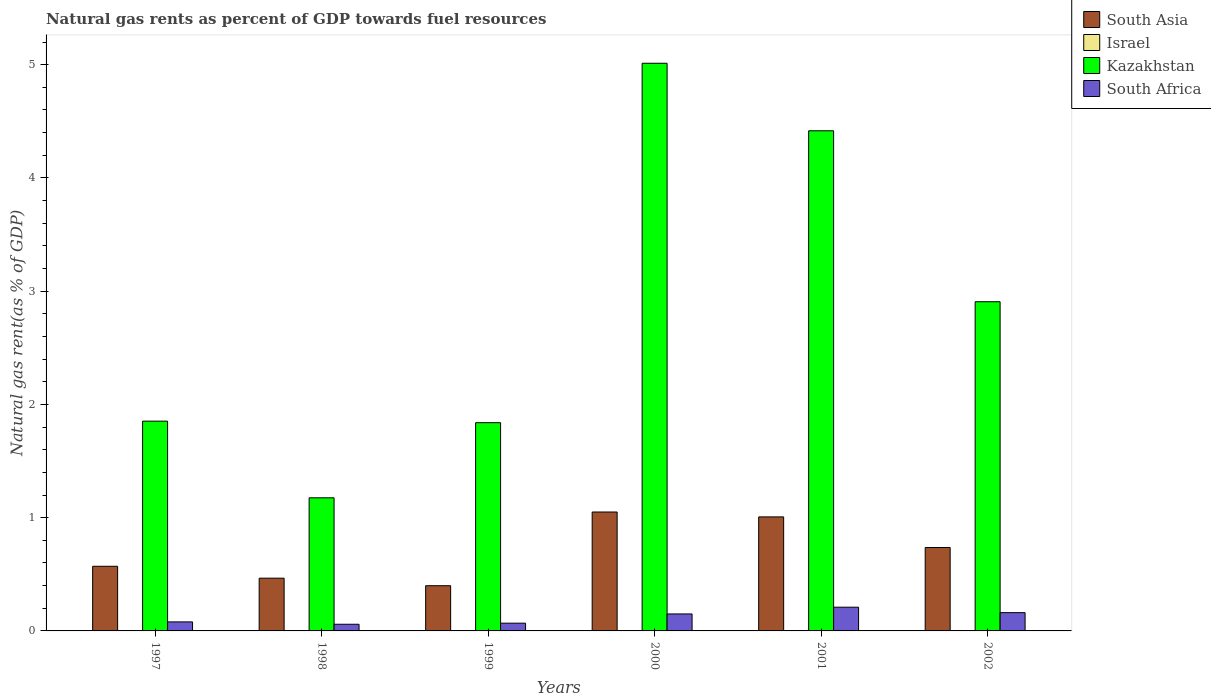How many groups of bars are there?
Your answer should be compact. 6. How many bars are there on the 4th tick from the left?
Provide a short and direct response. 4. How many bars are there on the 1st tick from the right?
Make the answer very short. 4. What is the natural gas rent in Kazakhstan in 2000?
Keep it short and to the point. 5.01. Across all years, what is the maximum natural gas rent in South Asia?
Make the answer very short. 1.05. Across all years, what is the minimum natural gas rent in Kazakhstan?
Your answer should be compact. 1.18. In which year was the natural gas rent in South Asia maximum?
Offer a terse response. 2000. In which year was the natural gas rent in South Africa minimum?
Your answer should be compact. 1998. What is the total natural gas rent in South Asia in the graph?
Offer a terse response. 4.23. What is the difference between the natural gas rent in Israel in 1997 and that in 2002?
Your answer should be compact. 0. What is the difference between the natural gas rent in South Africa in 1998 and the natural gas rent in South Asia in 2001?
Keep it short and to the point. -0.95. What is the average natural gas rent in South Africa per year?
Keep it short and to the point. 0.12. In the year 2000, what is the difference between the natural gas rent in Israel and natural gas rent in Kazakhstan?
Offer a very short reply. -5.01. What is the ratio of the natural gas rent in Kazakhstan in 1999 to that in 2001?
Offer a very short reply. 0.42. Is the natural gas rent in South Asia in 1999 less than that in 2000?
Your answer should be compact. Yes. Is the difference between the natural gas rent in Israel in 1997 and 1998 greater than the difference between the natural gas rent in Kazakhstan in 1997 and 1998?
Give a very brief answer. No. What is the difference between the highest and the second highest natural gas rent in Israel?
Give a very brief answer. 0. What is the difference between the highest and the lowest natural gas rent in South Asia?
Ensure brevity in your answer.  0.65. In how many years, is the natural gas rent in South Africa greater than the average natural gas rent in South Africa taken over all years?
Provide a short and direct response. 3. Is the sum of the natural gas rent in Kazakhstan in 1998 and 2000 greater than the maximum natural gas rent in South Asia across all years?
Give a very brief answer. Yes. How many bars are there?
Give a very brief answer. 24. Are all the bars in the graph horizontal?
Provide a short and direct response. No. How many years are there in the graph?
Your answer should be compact. 6. Are the values on the major ticks of Y-axis written in scientific E-notation?
Make the answer very short. No. Where does the legend appear in the graph?
Provide a succinct answer. Top right. How are the legend labels stacked?
Give a very brief answer. Vertical. What is the title of the graph?
Your answer should be very brief. Natural gas rents as percent of GDP towards fuel resources. Does "Italy" appear as one of the legend labels in the graph?
Offer a very short reply. No. What is the label or title of the Y-axis?
Provide a short and direct response. Natural gas rent(as % of GDP). What is the Natural gas rent(as % of GDP) of South Asia in 1997?
Your answer should be compact. 0.57. What is the Natural gas rent(as % of GDP) of Israel in 1997?
Offer a terse response. 0. What is the Natural gas rent(as % of GDP) of Kazakhstan in 1997?
Give a very brief answer. 1.85. What is the Natural gas rent(as % of GDP) in South Africa in 1997?
Provide a succinct answer. 0.08. What is the Natural gas rent(as % of GDP) of South Asia in 1998?
Offer a very short reply. 0.47. What is the Natural gas rent(as % of GDP) of Israel in 1998?
Offer a very short reply. 0. What is the Natural gas rent(as % of GDP) of Kazakhstan in 1998?
Offer a very short reply. 1.18. What is the Natural gas rent(as % of GDP) of South Africa in 1998?
Your response must be concise. 0.06. What is the Natural gas rent(as % of GDP) of South Asia in 1999?
Give a very brief answer. 0.4. What is the Natural gas rent(as % of GDP) in Israel in 1999?
Your response must be concise. 0. What is the Natural gas rent(as % of GDP) of Kazakhstan in 1999?
Your response must be concise. 1.84. What is the Natural gas rent(as % of GDP) in South Africa in 1999?
Keep it short and to the point. 0.07. What is the Natural gas rent(as % of GDP) of South Asia in 2000?
Keep it short and to the point. 1.05. What is the Natural gas rent(as % of GDP) in Israel in 2000?
Offer a terse response. 0. What is the Natural gas rent(as % of GDP) in Kazakhstan in 2000?
Keep it short and to the point. 5.01. What is the Natural gas rent(as % of GDP) in South Africa in 2000?
Make the answer very short. 0.15. What is the Natural gas rent(as % of GDP) in South Asia in 2001?
Ensure brevity in your answer.  1.01. What is the Natural gas rent(as % of GDP) of Israel in 2001?
Provide a succinct answer. 0. What is the Natural gas rent(as % of GDP) in Kazakhstan in 2001?
Provide a short and direct response. 4.42. What is the Natural gas rent(as % of GDP) of South Africa in 2001?
Your answer should be compact. 0.21. What is the Natural gas rent(as % of GDP) of South Asia in 2002?
Your response must be concise. 0.74. What is the Natural gas rent(as % of GDP) in Israel in 2002?
Make the answer very short. 0. What is the Natural gas rent(as % of GDP) in Kazakhstan in 2002?
Your answer should be very brief. 2.91. What is the Natural gas rent(as % of GDP) of South Africa in 2002?
Your answer should be very brief. 0.16. Across all years, what is the maximum Natural gas rent(as % of GDP) of South Asia?
Offer a terse response. 1.05. Across all years, what is the maximum Natural gas rent(as % of GDP) of Israel?
Ensure brevity in your answer.  0. Across all years, what is the maximum Natural gas rent(as % of GDP) of Kazakhstan?
Your response must be concise. 5.01. Across all years, what is the maximum Natural gas rent(as % of GDP) in South Africa?
Make the answer very short. 0.21. Across all years, what is the minimum Natural gas rent(as % of GDP) of South Asia?
Offer a very short reply. 0.4. Across all years, what is the minimum Natural gas rent(as % of GDP) in Israel?
Give a very brief answer. 0. Across all years, what is the minimum Natural gas rent(as % of GDP) of Kazakhstan?
Your answer should be very brief. 1.18. Across all years, what is the minimum Natural gas rent(as % of GDP) of South Africa?
Provide a short and direct response. 0.06. What is the total Natural gas rent(as % of GDP) in South Asia in the graph?
Your response must be concise. 4.23. What is the total Natural gas rent(as % of GDP) of Israel in the graph?
Give a very brief answer. 0. What is the total Natural gas rent(as % of GDP) in Kazakhstan in the graph?
Your response must be concise. 17.2. What is the total Natural gas rent(as % of GDP) of South Africa in the graph?
Provide a succinct answer. 0.73. What is the difference between the Natural gas rent(as % of GDP) in South Asia in 1997 and that in 1998?
Your answer should be compact. 0.11. What is the difference between the Natural gas rent(as % of GDP) in Kazakhstan in 1997 and that in 1998?
Provide a succinct answer. 0.68. What is the difference between the Natural gas rent(as % of GDP) of South Africa in 1997 and that in 1998?
Give a very brief answer. 0.02. What is the difference between the Natural gas rent(as % of GDP) in South Asia in 1997 and that in 1999?
Offer a terse response. 0.17. What is the difference between the Natural gas rent(as % of GDP) in Israel in 1997 and that in 1999?
Ensure brevity in your answer.  0. What is the difference between the Natural gas rent(as % of GDP) in Kazakhstan in 1997 and that in 1999?
Give a very brief answer. 0.01. What is the difference between the Natural gas rent(as % of GDP) of South Africa in 1997 and that in 1999?
Provide a short and direct response. 0.01. What is the difference between the Natural gas rent(as % of GDP) in South Asia in 1997 and that in 2000?
Provide a short and direct response. -0.48. What is the difference between the Natural gas rent(as % of GDP) of Kazakhstan in 1997 and that in 2000?
Offer a terse response. -3.16. What is the difference between the Natural gas rent(as % of GDP) in South Africa in 1997 and that in 2000?
Offer a terse response. -0.07. What is the difference between the Natural gas rent(as % of GDP) of South Asia in 1997 and that in 2001?
Offer a terse response. -0.44. What is the difference between the Natural gas rent(as % of GDP) of Kazakhstan in 1997 and that in 2001?
Your answer should be very brief. -2.56. What is the difference between the Natural gas rent(as % of GDP) of South Africa in 1997 and that in 2001?
Offer a terse response. -0.13. What is the difference between the Natural gas rent(as % of GDP) of South Asia in 1997 and that in 2002?
Offer a terse response. -0.17. What is the difference between the Natural gas rent(as % of GDP) of Israel in 1997 and that in 2002?
Your answer should be very brief. 0. What is the difference between the Natural gas rent(as % of GDP) of Kazakhstan in 1997 and that in 2002?
Provide a short and direct response. -1.05. What is the difference between the Natural gas rent(as % of GDP) in South Africa in 1997 and that in 2002?
Provide a succinct answer. -0.08. What is the difference between the Natural gas rent(as % of GDP) of South Asia in 1998 and that in 1999?
Your answer should be compact. 0.07. What is the difference between the Natural gas rent(as % of GDP) of Kazakhstan in 1998 and that in 1999?
Ensure brevity in your answer.  -0.66. What is the difference between the Natural gas rent(as % of GDP) in South Africa in 1998 and that in 1999?
Keep it short and to the point. -0.01. What is the difference between the Natural gas rent(as % of GDP) of South Asia in 1998 and that in 2000?
Your response must be concise. -0.58. What is the difference between the Natural gas rent(as % of GDP) in Israel in 1998 and that in 2000?
Your response must be concise. -0. What is the difference between the Natural gas rent(as % of GDP) in Kazakhstan in 1998 and that in 2000?
Make the answer very short. -3.84. What is the difference between the Natural gas rent(as % of GDP) of South Africa in 1998 and that in 2000?
Ensure brevity in your answer.  -0.09. What is the difference between the Natural gas rent(as % of GDP) in South Asia in 1998 and that in 2001?
Provide a succinct answer. -0.54. What is the difference between the Natural gas rent(as % of GDP) of Israel in 1998 and that in 2001?
Your answer should be very brief. -0. What is the difference between the Natural gas rent(as % of GDP) of Kazakhstan in 1998 and that in 2001?
Keep it short and to the point. -3.24. What is the difference between the Natural gas rent(as % of GDP) in South Africa in 1998 and that in 2001?
Ensure brevity in your answer.  -0.15. What is the difference between the Natural gas rent(as % of GDP) of South Asia in 1998 and that in 2002?
Provide a succinct answer. -0.27. What is the difference between the Natural gas rent(as % of GDP) in Israel in 1998 and that in 2002?
Ensure brevity in your answer.  -0. What is the difference between the Natural gas rent(as % of GDP) in Kazakhstan in 1998 and that in 2002?
Your response must be concise. -1.73. What is the difference between the Natural gas rent(as % of GDP) in South Africa in 1998 and that in 2002?
Give a very brief answer. -0.1. What is the difference between the Natural gas rent(as % of GDP) of South Asia in 1999 and that in 2000?
Provide a short and direct response. -0.65. What is the difference between the Natural gas rent(as % of GDP) in Israel in 1999 and that in 2000?
Your answer should be compact. -0. What is the difference between the Natural gas rent(as % of GDP) in Kazakhstan in 1999 and that in 2000?
Provide a succinct answer. -3.17. What is the difference between the Natural gas rent(as % of GDP) in South Africa in 1999 and that in 2000?
Keep it short and to the point. -0.08. What is the difference between the Natural gas rent(as % of GDP) of South Asia in 1999 and that in 2001?
Your answer should be very brief. -0.61. What is the difference between the Natural gas rent(as % of GDP) in Israel in 1999 and that in 2001?
Your answer should be compact. -0. What is the difference between the Natural gas rent(as % of GDP) of Kazakhstan in 1999 and that in 2001?
Provide a succinct answer. -2.58. What is the difference between the Natural gas rent(as % of GDP) in South Africa in 1999 and that in 2001?
Your response must be concise. -0.14. What is the difference between the Natural gas rent(as % of GDP) in South Asia in 1999 and that in 2002?
Make the answer very short. -0.34. What is the difference between the Natural gas rent(as % of GDP) of Israel in 1999 and that in 2002?
Provide a short and direct response. -0. What is the difference between the Natural gas rent(as % of GDP) in Kazakhstan in 1999 and that in 2002?
Give a very brief answer. -1.07. What is the difference between the Natural gas rent(as % of GDP) of South Africa in 1999 and that in 2002?
Your response must be concise. -0.09. What is the difference between the Natural gas rent(as % of GDP) in South Asia in 2000 and that in 2001?
Ensure brevity in your answer.  0.04. What is the difference between the Natural gas rent(as % of GDP) in Kazakhstan in 2000 and that in 2001?
Make the answer very short. 0.6. What is the difference between the Natural gas rent(as % of GDP) of South Africa in 2000 and that in 2001?
Offer a terse response. -0.06. What is the difference between the Natural gas rent(as % of GDP) in South Asia in 2000 and that in 2002?
Make the answer very short. 0.31. What is the difference between the Natural gas rent(as % of GDP) of Kazakhstan in 2000 and that in 2002?
Give a very brief answer. 2.11. What is the difference between the Natural gas rent(as % of GDP) of South Africa in 2000 and that in 2002?
Make the answer very short. -0.01. What is the difference between the Natural gas rent(as % of GDP) of South Asia in 2001 and that in 2002?
Offer a very short reply. 0.27. What is the difference between the Natural gas rent(as % of GDP) in Israel in 2001 and that in 2002?
Ensure brevity in your answer.  0. What is the difference between the Natural gas rent(as % of GDP) of Kazakhstan in 2001 and that in 2002?
Provide a short and direct response. 1.51. What is the difference between the Natural gas rent(as % of GDP) in South Africa in 2001 and that in 2002?
Provide a succinct answer. 0.05. What is the difference between the Natural gas rent(as % of GDP) in South Asia in 1997 and the Natural gas rent(as % of GDP) in Israel in 1998?
Offer a terse response. 0.57. What is the difference between the Natural gas rent(as % of GDP) of South Asia in 1997 and the Natural gas rent(as % of GDP) of Kazakhstan in 1998?
Provide a short and direct response. -0.6. What is the difference between the Natural gas rent(as % of GDP) in South Asia in 1997 and the Natural gas rent(as % of GDP) in South Africa in 1998?
Provide a succinct answer. 0.51. What is the difference between the Natural gas rent(as % of GDP) of Israel in 1997 and the Natural gas rent(as % of GDP) of Kazakhstan in 1998?
Provide a succinct answer. -1.17. What is the difference between the Natural gas rent(as % of GDP) of Israel in 1997 and the Natural gas rent(as % of GDP) of South Africa in 1998?
Offer a terse response. -0.06. What is the difference between the Natural gas rent(as % of GDP) in Kazakhstan in 1997 and the Natural gas rent(as % of GDP) in South Africa in 1998?
Provide a short and direct response. 1.79. What is the difference between the Natural gas rent(as % of GDP) of South Asia in 1997 and the Natural gas rent(as % of GDP) of Israel in 1999?
Your response must be concise. 0.57. What is the difference between the Natural gas rent(as % of GDP) in South Asia in 1997 and the Natural gas rent(as % of GDP) in Kazakhstan in 1999?
Provide a short and direct response. -1.27. What is the difference between the Natural gas rent(as % of GDP) of South Asia in 1997 and the Natural gas rent(as % of GDP) of South Africa in 1999?
Provide a succinct answer. 0.5. What is the difference between the Natural gas rent(as % of GDP) in Israel in 1997 and the Natural gas rent(as % of GDP) in Kazakhstan in 1999?
Offer a terse response. -1.84. What is the difference between the Natural gas rent(as % of GDP) in Israel in 1997 and the Natural gas rent(as % of GDP) in South Africa in 1999?
Make the answer very short. -0.07. What is the difference between the Natural gas rent(as % of GDP) in Kazakhstan in 1997 and the Natural gas rent(as % of GDP) in South Africa in 1999?
Your answer should be compact. 1.78. What is the difference between the Natural gas rent(as % of GDP) of South Asia in 1997 and the Natural gas rent(as % of GDP) of Israel in 2000?
Offer a very short reply. 0.57. What is the difference between the Natural gas rent(as % of GDP) of South Asia in 1997 and the Natural gas rent(as % of GDP) of Kazakhstan in 2000?
Ensure brevity in your answer.  -4.44. What is the difference between the Natural gas rent(as % of GDP) in South Asia in 1997 and the Natural gas rent(as % of GDP) in South Africa in 2000?
Provide a succinct answer. 0.42. What is the difference between the Natural gas rent(as % of GDP) of Israel in 1997 and the Natural gas rent(as % of GDP) of Kazakhstan in 2000?
Give a very brief answer. -5.01. What is the difference between the Natural gas rent(as % of GDP) of Israel in 1997 and the Natural gas rent(as % of GDP) of South Africa in 2000?
Provide a short and direct response. -0.15. What is the difference between the Natural gas rent(as % of GDP) in Kazakhstan in 1997 and the Natural gas rent(as % of GDP) in South Africa in 2000?
Give a very brief answer. 1.7. What is the difference between the Natural gas rent(as % of GDP) of South Asia in 1997 and the Natural gas rent(as % of GDP) of Israel in 2001?
Offer a very short reply. 0.57. What is the difference between the Natural gas rent(as % of GDP) in South Asia in 1997 and the Natural gas rent(as % of GDP) in Kazakhstan in 2001?
Ensure brevity in your answer.  -3.85. What is the difference between the Natural gas rent(as % of GDP) of South Asia in 1997 and the Natural gas rent(as % of GDP) of South Africa in 2001?
Make the answer very short. 0.36. What is the difference between the Natural gas rent(as % of GDP) in Israel in 1997 and the Natural gas rent(as % of GDP) in Kazakhstan in 2001?
Offer a terse response. -4.42. What is the difference between the Natural gas rent(as % of GDP) of Israel in 1997 and the Natural gas rent(as % of GDP) of South Africa in 2001?
Your answer should be very brief. -0.21. What is the difference between the Natural gas rent(as % of GDP) in Kazakhstan in 1997 and the Natural gas rent(as % of GDP) in South Africa in 2001?
Ensure brevity in your answer.  1.64. What is the difference between the Natural gas rent(as % of GDP) in South Asia in 1997 and the Natural gas rent(as % of GDP) in Israel in 2002?
Ensure brevity in your answer.  0.57. What is the difference between the Natural gas rent(as % of GDP) in South Asia in 1997 and the Natural gas rent(as % of GDP) in Kazakhstan in 2002?
Your answer should be compact. -2.34. What is the difference between the Natural gas rent(as % of GDP) of South Asia in 1997 and the Natural gas rent(as % of GDP) of South Africa in 2002?
Your response must be concise. 0.41. What is the difference between the Natural gas rent(as % of GDP) of Israel in 1997 and the Natural gas rent(as % of GDP) of Kazakhstan in 2002?
Ensure brevity in your answer.  -2.91. What is the difference between the Natural gas rent(as % of GDP) of Israel in 1997 and the Natural gas rent(as % of GDP) of South Africa in 2002?
Keep it short and to the point. -0.16. What is the difference between the Natural gas rent(as % of GDP) of Kazakhstan in 1997 and the Natural gas rent(as % of GDP) of South Africa in 2002?
Your answer should be very brief. 1.69. What is the difference between the Natural gas rent(as % of GDP) of South Asia in 1998 and the Natural gas rent(as % of GDP) of Israel in 1999?
Offer a very short reply. 0.47. What is the difference between the Natural gas rent(as % of GDP) of South Asia in 1998 and the Natural gas rent(as % of GDP) of Kazakhstan in 1999?
Offer a terse response. -1.37. What is the difference between the Natural gas rent(as % of GDP) in South Asia in 1998 and the Natural gas rent(as % of GDP) in South Africa in 1999?
Offer a terse response. 0.4. What is the difference between the Natural gas rent(as % of GDP) of Israel in 1998 and the Natural gas rent(as % of GDP) of Kazakhstan in 1999?
Your answer should be compact. -1.84. What is the difference between the Natural gas rent(as % of GDP) of Israel in 1998 and the Natural gas rent(as % of GDP) of South Africa in 1999?
Offer a terse response. -0.07. What is the difference between the Natural gas rent(as % of GDP) of Kazakhstan in 1998 and the Natural gas rent(as % of GDP) of South Africa in 1999?
Offer a very short reply. 1.11. What is the difference between the Natural gas rent(as % of GDP) of South Asia in 1998 and the Natural gas rent(as % of GDP) of Israel in 2000?
Make the answer very short. 0.46. What is the difference between the Natural gas rent(as % of GDP) of South Asia in 1998 and the Natural gas rent(as % of GDP) of Kazakhstan in 2000?
Provide a short and direct response. -4.55. What is the difference between the Natural gas rent(as % of GDP) in South Asia in 1998 and the Natural gas rent(as % of GDP) in South Africa in 2000?
Give a very brief answer. 0.32. What is the difference between the Natural gas rent(as % of GDP) in Israel in 1998 and the Natural gas rent(as % of GDP) in Kazakhstan in 2000?
Give a very brief answer. -5.01. What is the difference between the Natural gas rent(as % of GDP) in Israel in 1998 and the Natural gas rent(as % of GDP) in South Africa in 2000?
Provide a succinct answer. -0.15. What is the difference between the Natural gas rent(as % of GDP) of Kazakhstan in 1998 and the Natural gas rent(as % of GDP) of South Africa in 2000?
Offer a terse response. 1.03. What is the difference between the Natural gas rent(as % of GDP) of South Asia in 1998 and the Natural gas rent(as % of GDP) of Israel in 2001?
Keep it short and to the point. 0.46. What is the difference between the Natural gas rent(as % of GDP) of South Asia in 1998 and the Natural gas rent(as % of GDP) of Kazakhstan in 2001?
Your response must be concise. -3.95. What is the difference between the Natural gas rent(as % of GDP) in South Asia in 1998 and the Natural gas rent(as % of GDP) in South Africa in 2001?
Provide a short and direct response. 0.26. What is the difference between the Natural gas rent(as % of GDP) in Israel in 1998 and the Natural gas rent(as % of GDP) in Kazakhstan in 2001?
Keep it short and to the point. -4.42. What is the difference between the Natural gas rent(as % of GDP) in Israel in 1998 and the Natural gas rent(as % of GDP) in South Africa in 2001?
Give a very brief answer. -0.21. What is the difference between the Natural gas rent(as % of GDP) of Kazakhstan in 1998 and the Natural gas rent(as % of GDP) of South Africa in 2001?
Provide a short and direct response. 0.97. What is the difference between the Natural gas rent(as % of GDP) in South Asia in 1998 and the Natural gas rent(as % of GDP) in Israel in 2002?
Your response must be concise. 0.47. What is the difference between the Natural gas rent(as % of GDP) of South Asia in 1998 and the Natural gas rent(as % of GDP) of Kazakhstan in 2002?
Your answer should be compact. -2.44. What is the difference between the Natural gas rent(as % of GDP) of South Asia in 1998 and the Natural gas rent(as % of GDP) of South Africa in 2002?
Provide a short and direct response. 0.3. What is the difference between the Natural gas rent(as % of GDP) in Israel in 1998 and the Natural gas rent(as % of GDP) in Kazakhstan in 2002?
Offer a terse response. -2.91. What is the difference between the Natural gas rent(as % of GDP) in Israel in 1998 and the Natural gas rent(as % of GDP) in South Africa in 2002?
Your response must be concise. -0.16. What is the difference between the Natural gas rent(as % of GDP) of Kazakhstan in 1998 and the Natural gas rent(as % of GDP) of South Africa in 2002?
Offer a terse response. 1.01. What is the difference between the Natural gas rent(as % of GDP) of South Asia in 1999 and the Natural gas rent(as % of GDP) of Israel in 2000?
Make the answer very short. 0.4. What is the difference between the Natural gas rent(as % of GDP) in South Asia in 1999 and the Natural gas rent(as % of GDP) in Kazakhstan in 2000?
Give a very brief answer. -4.61. What is the difference between the Natural gas rent(as % of GDP) in South Asia in 1999 and the Natural gas rent(as % of GDP) in South Africa in 2000?
Offer a very short reply. 0.25. What is the difference between the Natural gas rent(as % of GDP) of Israel in 1999 and the Natural gas rent(as % of GDP) of Kazakhstan in 2000?
Make the answer very short. -5.01. What is the difference between the Natural gas rent(as % of GDP) of Israel in 1999 and the Natural gas rent(as % of GDP) of South Africa in 2000?
Provide a succinct answer. -0.15. What is the difference between the Natural gas rent(as % of GDP) of Kazakhstan in 1999 and the Natural gas rent(as % of GDP) of South Africa in 2000?
Make the answer very short. 1.69. What is the difference between the Natural gas rent(as % of GDP) of South Asia in 1999 and the Natural gas rent(as % of GDP) of Israel in 2001?
Provide a succinct answer. 0.4. What is the difference between the Natural gas rent(as % of GDP) in South Asia in 1999 and the Natural gas rent(as % of GDP) in Kazakhstan in 2001?
Offer a very short reply. -4.02. What is the difference between the Natural gas rent(as % of GDP) of South Asia in 1999 and the Natural gas rent(as % of GDP) of South Africa in 2001?
Provide a succinct answer. 0.19. What is the difference between the Natural gas rent(as % of GDP) in Israel in 1999 and the Natural gas rent(as % of GDP) in Kazakhstan in 2001?
Provide a short and direct response. -4.42. What is the difference between the Natural gas rent(as % of GDP) in Israel in 1999 and the Natural gas rent(as % of GDP) in South Africa in 2001?
Make the answer very short. -0.21. What is the difference between the Natural gas rent(as % of GDP) of Kazakhstan in 1999 and the Natural gas rent(as % of GDP) of South Africa in 2001?
Your answer should be compact. 1.63. What is the difference between the Natural gas rent(as % of GDP) in South Asia in 1999 and the Natural gas rent(as % of GDP) in Israel in 2002?
Make the answer very short. 0.4. What is the difference between the Natural gas rent(as % of GDP) in South Asia in 1999 and the Natural gas rent(as % of GDP) in Kazakhstan in 2002?
Offer a very short reply. -2.51. What is the difference between the Natural gas rent(as % of GDP) in South Asia in 1999 and the Natural gas rent(as % of GDP) in South Africa in 2002?
Ensure brevity in your answer.  0.24. What is the difference between the Natural gas rent(as % of GDP) of Israel in 1999 and the Natural gas rent(as % of GDP) of Kazakhstan in 2002?
Your response must be concise. -2.91. What is the difference between the Natural gas rent(as % of GDP) in Israel in 1999 and the Natural gas rent(as % of GDP) in South Africa in 2002?
Offer a very short reply. -0.16. What is the difference between the Natural gas rent(as % of GDP) in Kazakhstan in 1999 and the Natural gas rent(as % of GDP) in South Africa in 2002?
Provide a short and direct response. 1.68. What is the difference between the Natural gas rent(as % of GDP) of South Asia in 2000 and the Natural gas rent(as % of GDP) of Israel in 2001?
Offer a terse response. 1.05. What is the difference between the Natural gas rent(as % of GDP) of South Asia in 2000 and the Natural gas rent(as % of GDP) of Kazakhstan in 2001?
Ensure brevity in your answer.  -3.37. What is the difference between the Natural gas rent(as % of GDP) in South Asia in 2000 and the Natural gas rent(as % of GDP) in South Africa in 2001?
Your answer should be very brief. 0.84. What is the difference between the Natural gas rent(as % of GDP) in Israel in 2000 and the Natural gas rent(as % of GDP) in Kazakhstan in 2001?
Offer a terse response. -4.42. What is the difference between the Natural gas rent(as % of GDP) of Israel in 2000 and the Natural gas rent(as % of GDP) of South Africa in 2001?
Provide a short and direct response. -0.21. What is the difference between the Natural gas rent(as % of GDP) in Kazakhstan in 2000 and the Natural gas rent(as % of GDP) in South Africa in 2001?
Keep it short and to the point. 4.8. What is the difference between the Natural gas rent(as % of GDP) in South Asia in 2000 and the Natural gas rent(as % of GDP) in Israel in 2002?
Ensure brevity in your answer.  1.05. What is the difference between the Natural gas rent(as % of GDP) of South Asia in 2000 and the Natural gas rent(as % of GDP) of Kazakhstan in 2002?
Ensure brevity in your answer.  -1.86. What is the difference between the Natural gas rent(as % of GDP) of South Asia in 2000 and the Natural gas rent(as % of GDP) of South Africa in 2002?
Your response must be concise. 0.89. What is the difference between the Natural gas rent(as % of GDP) of Israel in 2000 and the Natural gas rent(as % of GDP) of Kazakhstan in 2002?
Offer a terse response. -2.91. What is the difference between the Natural gas rent(as % of GDP) in Israel in 2000 and the Natural gas rent(as % of GDP) in South Africa in 2002?
Your answer should be very brief. -0.16. What is the difference between the Natural gas rent(as % of GDP) of Kazakhstan in 2000 and the Natural gas rent(as % of GDP) of South Africa in 2002?
Provide a succinct answer. 4.85. What is the difference between the Natural gas rent(as % of GDP) of South Asia in 2001 and the Natural gas rent(as % of GDP) of South Africa in 2002?
Your answer should be compact. 0.85. What is the difference between the Natural gas rent(as % of GDP) in Israel in 2001 and the Natural gas rent(as % of GDP) in Kazakhstan in 2002?
Offer a very short reply. -2.91. What is the difference between the Natural gas rent(as % of GDP) of Israel in 2001 and the Natural gas rent(as % of GDP) of South Africa in 2002?
Give a very brief answer. -0.16. What is the difference between the Natural gas rent(as % of GDP) in Kazakhstan in 2001 and the Natural gas rent(as % of GDP) in South Africa in 2002?
Offer a terse response. 4.25. What is the average Natural gas rent(as % of GDP) of South Asia per year?
Ensure brevity in your answer.  0.7. What is the average Natural gas rent(as % of GDP) of Israel per year?
Keep it short and to the point. 0. What is the average Natural gas rent(as % of GDP) of Kazakhstan per year?
Offer a very short reply. 2.87. What is the average Natural gas rent(as % of GDP) of South Africa per year?
Your answer should be very brief. 0.12. In the year 1997, what is the difference between the Natural gas rent(as % of GDP) of South Asia and Natural gas rent(as % of GDP) of Israel?
Ensure brevity in your answer.  0.57. In the year 1997, what is the difference between the Natural gas rent(as % of GDP) in South Asia and Natural gas rent(as % of GDP) in Kazakhstan?
Give a very brief answer. -1.28. In the year 1997, what is the difference between the Natural gas rent(as % of GDP) of South Asia and Natural gas rent(as % of GDP) of South Africa?
Keep it short and to the point. 0.49. In the year 1997, what is the difference between the Natural gas rent(as % of GDP) in Israel and Natural gas rent(as % of GDP) in Kazakhstan?
Make the answer very short. -1.85. In the year 1997, what is the difference between the Natural gas rent(as % of GDP) of Israel and Natural gas rent(as % of GDP) of South Africa?
Your answer should be very brief. -0.08. In the year 1997, what is the difference between the Natural gas rent(as % of GDP) of Kazakhstan and Natural gas rent(as % of GDP) of South Africa?
Offer a very short reply. 1.77. In the year 1998, what is the difference between the Natural gas rent(as % of GDP) in South Asia and Natural gas rent(as % of GDP) in Israel?
Provide a succinct answer. 0.47. In the year 1998, what is the difference between the Natural gas rent(as % of GDP) of South Asia and Natural gas rent(as % of GDP) of Kazakhstan?
Offer a very short reply. -0.71. In the year 1998, what is the difference between the Natural gas rent(as % of GDP) of South Asia and Natural gas rent(as % of GDP) of South Africa?
Ensure brevity in your answer.  0.41. In the year 1998, what is the difference between the Natural gas rent(as % of GDP) in Israel and Natural gas rent(as % of GDP) in Kazakhstan?
Provide a short and direct response. -1.17. In the year 1998, what is the difference between the Natural gas rent(as % of GDP) of Israel and Natural gas rent(as % of GDP) of South Africa?
Your answer should be very brief. -0.06. In the year 1998, what is the difference between the Natural gas rent(as % of GDP) of Kazakhstan and Natural gas rent(as % of GDP) of South Africa?
Your answer should be very brief. 1.12. In the year 1999, what is the difference between the Natural gas rent(as % of GDP) in South Asia and Natural gas rent(as % of GDP) in Israel?
Offer a terse response. 0.4. In the year 1999, what is the difference between the Natural gas rent(as % of GDP) of South Asia and Natural gas rent(as % of GDP) of Kazakhstan?
Offer a very short reply. -1.44. In the year 1999, what is the difference between the Natural gas rent(as % of GDP) in South Asia and Natural gas rent(as % of GDP) in South Africa?
Your response must be concise. 0.33. In the year 1999, what is the difference between the Natural gas rent(as % of GDP) of Israel and Natural gas rent(as % of GDP) of Kazakhstan?
Your answer should be compact. -1.84. In the year 1999, what is the difference between the Natural gas rent(as % of GDP) in Israel and Natural gas rent(as % of GDP) in South Africa?
Keep it short and to the point. -0.07. In the year 1999, what is the difference between the Natural gas rent(as % of GDP) of Kazakhstan and Natural gas rent(as % of GDP) of South Africa?
Ensure brevity in your answer.  1.77. In the year 2000, what is the difference between the Natural gas rent(as % of GDP) of South Asia and Natural gas rent(as % of GDP) of Israel?
Offer a terse response. 1.05. In the year 2000, what is the difference between the Natural gas rent(as % of GDP) in South Asia and Natural gas rent(as % of GDP) in Kazakhstan?
Your answer should be compact. -3.96. In the year 2000, what is the difference between the Natural gas rent(as % of GDP) of South Asia and Natural gas rent(as % of GDP) of South Africa?
Keep it short and to the point. 0.9. In the year 2000, what is the difference between the Natural gas rent(as % of GDP) in Israel and Natural gas rent(as % of GDP) in Kazakhstan?
Give a very brief answer. -5.01. In the year 2000, what is the difference between the Natural gas rent(as % of GDP) in Israel and Natural gas rent(as % of GDP) in South Africa?
Offer a very short reply. -0.15. In the year 2000, what is the difference between the Natural gas rent(as % of GDP) in Kazakhstan and Natural gas rent(as % of GDP) in South Africa?
Keep it short and to the point. 4.86. In the year 2001, what is the difference between the Natural gas rent(as % of GDP) of South Asia and Natural gas rent(as % of GDP) of Israel?
Your response must be concise. 1.01. In the year 2001, what is the difference between the Natural gas rent(as % of GDP) of South Asia and Natural gas rent(as % of GDP) of Kazakhstan?
Offer a terse response. -3.41. In the year 2001, what is the difference between the Natural gas rent(as % of GDP) of South Asia and Natural gas rent(as % of GDP) of South Africa?
Your answer should be very brief. 0.8. In the year 2001, what is the difference between the Natural gas rent(as % of GDP) of Israel and Natural gas rent(as % of GDP) of Kazakhstan?
Keep it short and to the point. -4.42. In the year 2001, what is the difference between the Natural gas rent(as % of GDP) of Israel and Natural gas rent(as % of GDP) of South Africa?
Provide a succinct answer. -0.21. In the year 2001, what is the difference between the Natural gas rent(as % of GDP) of Kazakhstan and Natural gas rent(as % of GDP) of South Africa?
Offer a terse response. 4.21. In the year 2002, what is the difference between the Natural gas rent(as % of GDP) in South Asia and Natural gas rent(as % of GDP) in Israel?
Your response must be concise. 0.74. In the year 2002, what is the difference between the Natural gas rent(as % of GDP) in South Asia and Natural gas rent(as % of GDP) in Kazakhstan?
Your answer should be compact. -2.17. In the year 2002, what is the difference between the Natural gas rent(as % of GDP) of South Asia and Natural gas rent(as % of GDP) of South Africa?
Your answer should be compact. 0.58. In the year 2002, what is the difference between the Natural gas rent(as % of GDP) in Israel and Natural gas rent(as % of GDP) in Kazakhstan?
Ensure brevity in your answer.  -2.91. In the year 2002, what is the difference between the Natural gas rent(as % of GDP) in Israel and Natural gas rent(as % of GDP) in South Africa?
Provide a short and direct response. -0.16. In the year 2002, what is the difference between the Natural gas rent(as % of GDP) in Kazakhstan and Natural gas rent(as % of GDP) in South Africa?
Make the answer very short. 2.75. What is the ratio of the Natural gas rent(as % of GDP) of South Asia in 1997 to that in 1998?
Offer a terse response. 1.23. What is the ratio of the Natural gas rent(as % of GDP) of Israel in 1997 to that in 1998?
Your answer should be very brief. 1.8. What is the ratio of the Natural gas rent(as % of GDP) in Kazakhstan in 1997 to that in 1998?
Provide a short and direct response. 1.58. What is the ratio of the Natural gas rent(as % of GDP) in South Africa in 1997 to that in 1998?
Ensure brevity in your answer.  1.36. What is the ratio of the Natural gas rent(as % of GDP) of South Asia in 1997 to that in 1999?
Offer a terse response. 1.43. What is the ratio of the Natural gas rent(as % of GDP) in Israel in 1997 to that in 1999?
Your response must be concise. 2.35. What is the ratio of the Natural gas rent(as % of GDP) in Kazakhstan in 1997 to that in 1999?
Give a very brief answer. 1.01. What is the ratio of the Natural gas rent(as % of GDP) in South Africa in 1997 to that in 1999?
Your answer should be compact. 1.16. What is the ratio of the Natural gas rent(as % of GDP) of South Asia in 1997 to that in 2000?
Offer a terse response. 0.54. What is the ratio of the Natural gas rent(as % of GDP) in Israel in 1997 to that in 2000?
Ensure brevity in your answer.  1.16. What is the ratio of the Natural gas rent(as % of GDP) in Kazakhstan in 1997 to that in 2000?
Offer a terse response. 0.37. What is the ratio of the Natural gas rent(as % of GDP) in South Africa in 1997 to that in 2000?
Provide a succinct answer. 0.53. What is the ratio of the Natural gas rent(as % of GDP) of South Asia in 1997 to that in 2001?
Give a very brief answer. 0.57. What is the ratio of the Natural gas rent(as % of GDP) of Israel in 1997 to that in 2001?
Provide a succinct answer. 1.19. What is the ratio of the Natural gas rent(as % of GDP) in Kazakhstan in 1997 to that in 2001?
Ensure brevity in your answer.  0.42. What is the ratio of the Natural gas rent(as % of GDP) in South Africa in 1997 to that in 2001?
Provide a succinct answer. 0.38. What is the ratio of the Natural gas rent(as % of GDP) in South Asia in 1997 to that in 2002?
Your answer should be very brief. 0.78. What is the ratio of the Natural gas rent(as % of GDP) of Israel in 1997 to that in 2002?
Your answer should be very brief. 1.63. What is the ratio of the Natural gas rent(as % of GDP) of Kazakhstan in 1997 to that in 2002?
Offer a very short reply. 0.64. What is the ratio of the Natural gas rent(as % of GDP) in South Africa in 1997 to that in 2002?
Ensure brevity in your answer.  0.49. What is the ratio of the Natural gas rent(as % of GDP) of South Asia in 1998 to that in 1999?
Keep it short and to the point. 1.17. What is the ratio of the Natural gas rent(as % of GDP) of Israel in 1998 to that in 1999?
Ensure brevity in your answer.  1.3. What is the ratio of the Natural gas rent(as % of GDP) in Kazakhstan in 1998 to that in 1999?
Your answer should be compact. 0.64. What is the ratio of the Natural gas rent(as % of GDP) in South Africa in 1998 to that in 1999?
Offer a terse response. 0.86. What is the ratio of the Natural gas rent(as % of GDP) of South Asia in 1998 to that in 2000?
Your answer should be very brief. 0.44. What is the ratio of the Natural gas rent(as % of GDP) in Israel in 1998 to that in 2000?
Ensure brevity in your answer.  0.64. What is the ratio of the Natural gas rent(as % of GDP) of Kazakhstan in 1998 to that in 2000?
Your answer should be compact. 0.23. What is the ratio of the Natural gas rent(as % of GDP) in South Africa in 1998 to that in 2000?
Provide a succinct answer. 0.39. What is the ratio of the Natural gas rent(as % of GDP) of South Asia in 1998 to that in 2001?
Your answer should be compact. 0.46. What is the ratio of the Natural gas rent(as % of GDP) in Israel in 1998 to that in 2001?
Keep it short and to the point. 0.66. What is the ratio of the Natural gas rent(as % of GDP) of Kazakhstan in 1998 to that in 2001?
Give a very brief answer. 0.27. What is the ratio of the Natural gas rent(as % of GDP) of South Africa in 1998 to that in 2001?
Your answer should be very brief. 0.28. What is the ratio of the Natural gas rent(as % of GDP) of South Asia in 1998 to that in 2002?
Your answer should be compact. 0.63. What is the ratio of the Natural gas rent(as % of GDP) in Israel in 1998 to that in 2002?
Make the answer very short. 0.9. What is the ratio of the Natural gas rent(as % of GDP) in Kazakhstan in 1998 to that in 2002?
Keep it short and to the point. 0.4. What is the ratio of the Natural gas rent(as % of GDP) of South Africa in 1998 to that in 2002?
Your answer should be very brief. 0.36. What is the ratio of the Natural gas rent(as % of GDP) in South Asia in 1999 to that in 2000?
Make the answer very short. 0.38. What is the ratio of the Natural gas rent(as % of GDP) in Israel in 1999 to that in 2000?
Ensure brevity in your answer.  0.49. What is the ratio of the Natural gas rent(as % of GDP) in Kazakhstan in 1999 to that in 2000?
Provide a short and direct response. 0.37. What is the ratio of the Natural gas rent(as % of GDP) of South Africa in 1999 to that in 2000?
Give a very brief answer. 0.46. What is the ratio of the Natural gas rent(as % of GDP) of South Asia in 1999 to that in 2001?
Your response must be concise. 0.4. What is the ratio of the Natural gas rent(as % of GDP) of Israel in 1999 to that in 2001?
Ensure brevity in your answer.  0.51. What is the ratio of the Natural gas rent(as % of GDP) of Kazakhstan in 1999 to that in 2001?
Your response must be concise. 0.42. What is the ratio of the Natural gas rent(as % of GDP) of South Africa in 1999 to that in 2001?
Keep it short and to the point. 0.33. What is the ratio of the Natural gas rent(as % of GDP) in South Asia in 1999 to that in 2002?
Your answer should be very brief. 0.54. What is the ratio of the Natural gas rent(as % of GDP) of Israel in 1999 to that in 2002?
Give a very brief answer. 0.7. What is the ratio of the Natural gas rent(as % of GDP) in Kazakhstan in 1999 to that in 2002?
Your answer should be very brief. 0.63. What is the ratio of the Natural gas rent(as % of GDP) in South Africa in 1999 to that in 2002?
Make the answer very short. 0.42. What is the ratio of the Natural gas rent(as % of GDP) in South Asia in 2000 to that in 2001?
Your answer should be very brief. 1.04. What is the ratio of the Natural gas rent(as % of GDP) of Israel in 2000 to that in 2001?
Provide a succinct answer. 1.03. What is the ratio of the Natural gas rent(as % of GDP) of Kazakhstan in 2000 to that in 2001?
Provide a short and direct response. 1.14. What is the ratio of the Natural gas rent(as % of GDP) of South Africa in 2000 to that in 2001?
Your answer should be very brief. 0.72. What is the ratio of the Natural gas rent(as % of GDP) in South Asia in 2000 to that in 2002?
Keep it short and to the point. 1.43. What is the ratio of the Natural gas rent(as % of GDP) of Israel in 2000 to that in 2002?
Provide a succinct answer. 1.41. What is the ratio of the Natural gas rent(as % of GDP) in Kazakhstan in 2000 to that in 2002?
Your answer should be compact. 1.72. What is the ratio of the Natural gas rent(as % of GDP) of South Africa in 2000 to that in 2002?
Provide a succinct answer. 0.93. What is the ratio of the Natural gas rent(as % of GDP) of South Asia in 2001 to that in 2002?
Make the answer very short. 1.37. What is the ratio of the Natural gas rent(as % of GDP) in Israel in 2001 to that in 2002?
Offer a very short reply. 1.37. What is the ratio of the Natural gas rent(as % of GDP) in Kazakhstan in 2001 to that in 2002?
Give a very brief answer. 1.52. What is the ratio of the Natural gas rent(as % of GDP) of South Africa in 2001 to that in 2002?
Keep it short and to the point. 1.3. What is the difference between the highest and the second highest Natural gas rent(as % of GDP) of South Asia?
Offer a terse response. 0.04. What is the difference between the highest and the second highest Natural gas rent(as % of GDP) of Kazakhstan?
Offer a terse response. 0.6. What is the difference between the highest and the second highest Natural gas rent(as % of GDP) in South Africa?
Your response must be concise. 0.05. What is the difference between the highest and the lowest Natural gas rent(as % of GDP) in South Asia?
Your answer should be very brief. 0.65. What is the difference between the highest and the lowest Natural gas rent(as % of GDP) of Israel?
Provide a succinct answer. 0. What is the difference between the highest and the lowest Natural gas rent(as % of GDP) in Kazakhstan?
Provide a succinct answer. 3.84. What is the difference between the highest and the lowest Natural gas rent(as % of GDP) in South Africa?
Provide a short and direct response. 0.15. 